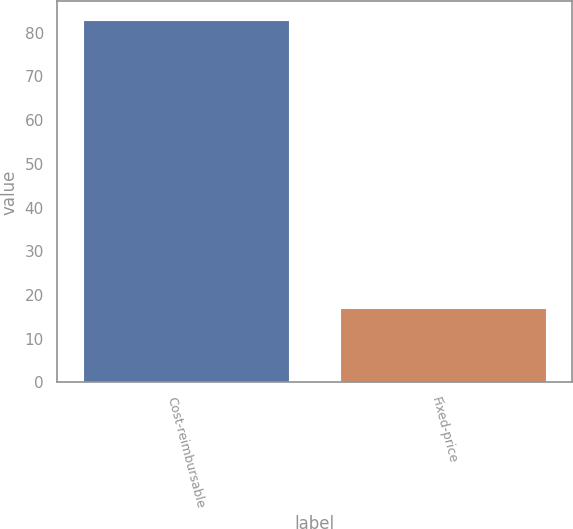<chart> <loc_0><loc_0><loc_500><loc_500><bar_chart><fcel>Cost-reimbursable<fcel>Fixed-price<nl><fcel>83<fcel>17<nl></chart> 